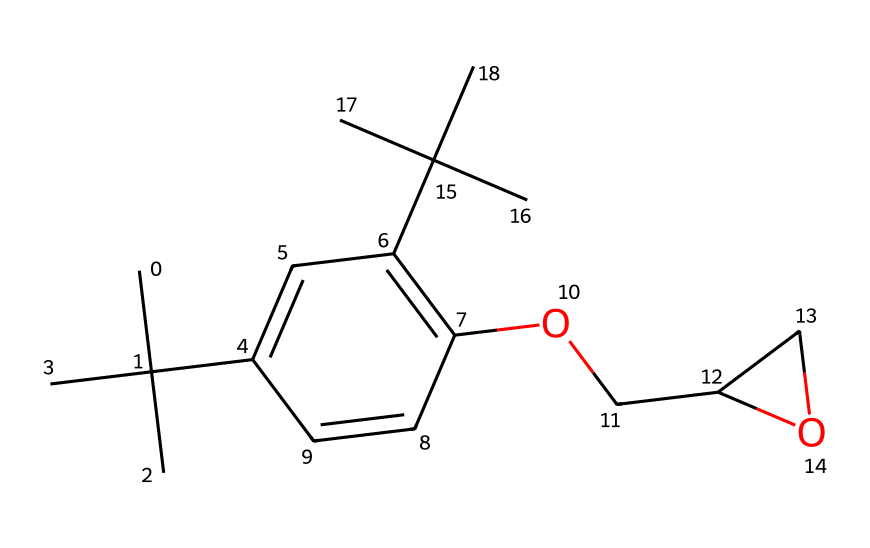What is the main functional group present in this epoxy resin? The structure contains an ether group (–O–) in the cycloaliphatic part, which indicates the presence of epoxy.
Answer: ether How many carbon atoms are in the chemical structure? By counting the carbon atoms in the SMILES representation, there are 20 carbon atoms, which is a fundamental aspect of the polymer.
Answer: 20 What is the total number of oxygen atoms in the structure? There are two oxygen atoms present in the structure, which contribute to the network formation in the polymer through crosslinking.
Answer: 2 Which part of the chemical structure contributes to its toughness and flexibility? The presence of the branched carbon chains (C(C)(C)) generally enhances toughness and flexibility in polymers, allowing for better performance under stress.
Answer: branched carbon chains What type of polymer does this chemical represent? This chemical represents a thermosetting polymer, as epoxy resins undergo curing and crosslinking upon heating or chemical activation, leading to a rigid structure.
Answer: thermosetting What is a likely application of this polymer in sports equipment? This polymer is commonly used in the manufacturing of golf club heads due to its high strength-to-weight ratio and durability, making it ideal for sports equipment.
Answer: golf club heads 